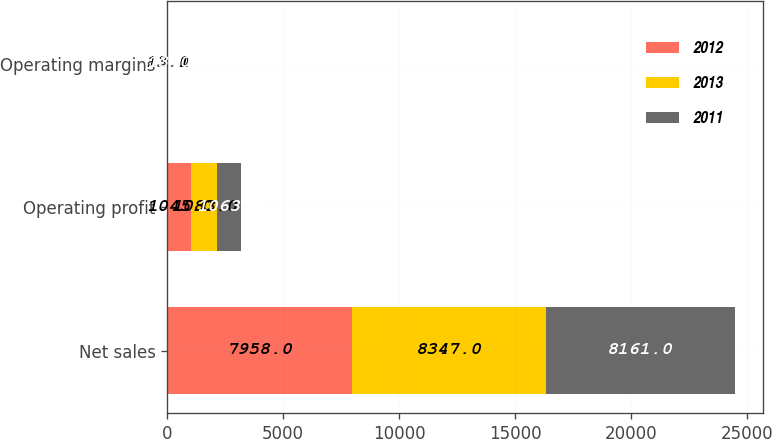Convert chart to OTSL. <chart><loc_0><loc_0><loc_500><loc_500><stacked_bar_chart><ecel><fcel>Net sales<fcel>Operating profit<fcel>Operating margins<nl><fcel>2012<fcel>7958<fcel>1045<fcel>13.1<nl><fcel>2013<fcel>8347<fcel>1083<fcel>13<nl><fcel>2011<fcel>8161<fcel>1063<fcel>13<nl></chart> 